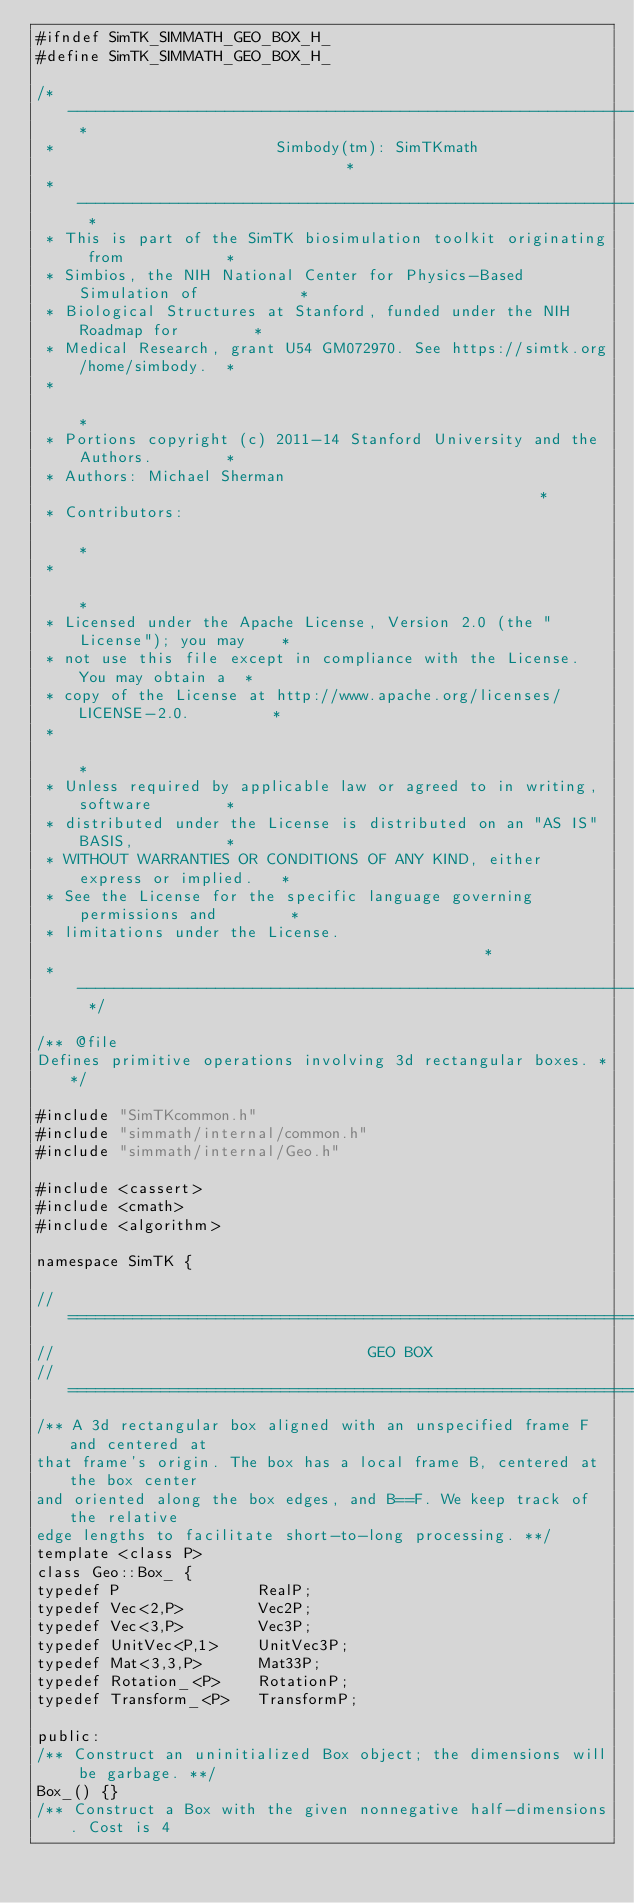Convert code to text. <code><loc_0><loc_0><loc_500><loc_500><_C_>#ifndef SimTK_SIMMATH_GEO_BOX_H_
#define SimTK_SIMMATH_GEO_BOX_H_

/* -------------------------------------------------------------------------- *
 *                        Simbody(tm): SimTKmath                              *
 * -------------------------------------------------------------------------- *
 * This is part of the SimTK biosimulation toolkit originating from           *
 * Simbios, the NIH National Center for Physics-Based Simulation of           *
 * Biological Structures at Stanford, funded under the NIH Roadmap for        *
 * Medical Research, grant U54 GM072970. See https://simtk.org/home/simbody.  *
 *                                                                            *
 * Portions copyright (c) 2011-14 Stanford University and the Authors.        *
 * Authors: Michael Sherman                                                   *
 * Contributors:                                                              *
 *                                                                            *
 * Licensed under the Apache License, Version 2.0 (the "License"); you may    *
 * not use this file except in compliance with the License. You may obtain a  *
 * copy of the License at http://www.apache.org/licenses/LICENSE-2.0.         *
 *                                                                            *
 * Unless required by applicable law or agreed to in writing, software        *
 * distributed under the License is distributed on an "AS IS" BASIS,          *
 * WITHOUT WARRANTIES OR CONDITIONS OF ANY KIND, either express or implied.   *
 * See the License for the specific language governing permissions and        *
 * limitations under the License.                                             *
 * -------------------------------------------------------------------------- */

/** @file
Defines primitive operations involving 3d rectangular boxes. **/

#include "SimTKcommon.h"
#include "simmath/internal/common.h"
#include "simmath/internal/Geo.h"

#include <cassert>
#include <cmath>
#include <algorithm>

namespace SimTK {

//==============================================================================
//                                  GEO BOX
//==============================================================================
/** A 3d rectangular box aligned with an unspecified frame F and centered at 
that frame's origin. The box has a local frame B, centered at the box center 
and oriented along the box edges, and B==F. We keep track of the relative
edge lengths to facilitate short-to-long processing. **/
template <class P>
class Geo::Box_ {
typedef P               RealP;
typedef Vec<2,P>        Vec2P;
typedef Vec<3,P>        Vec3P;
typedef UnitVec<P,1>    UnitVec3P;
typedef Mat<3,3,P>      Mat33P;
typedef Rotation_<P>    RotationP;
typedef Transform_<P>   TransformP;

public:
/** Construct an uninitialized Box object; the dimensions will be garbage. **/
Box_() {}
/** Construct a Box with the given nonnegative half-dimensions. Cost is 4</code> 